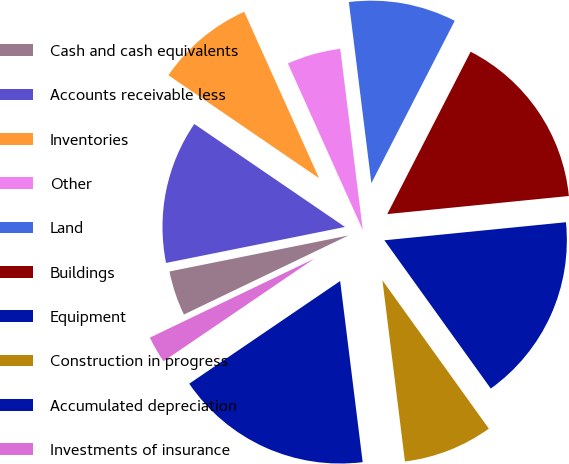Convert chart. <chart><loc_0><loc_0><loc_500><loc_500><pie_chart><fcel>Cash and cash equivalents<fcel>Accounts receivable less<fcel>Inventories<fcel>Other<fcel>Land<fcel>Buildings<fcel>Equipment<fcel>Construction in progress<fcel>Accumulated depreciation<fcel>Investments of insurance<nl><fcel>3.97%<fcel>12.7%<fcel>8.73%<fcel>4.76%<fcel>9.52%<fcel>15.87%<fcel>16.67%<fcel>7.94%<fcel>17.46%<fcel>2.38%<nl></chart> 